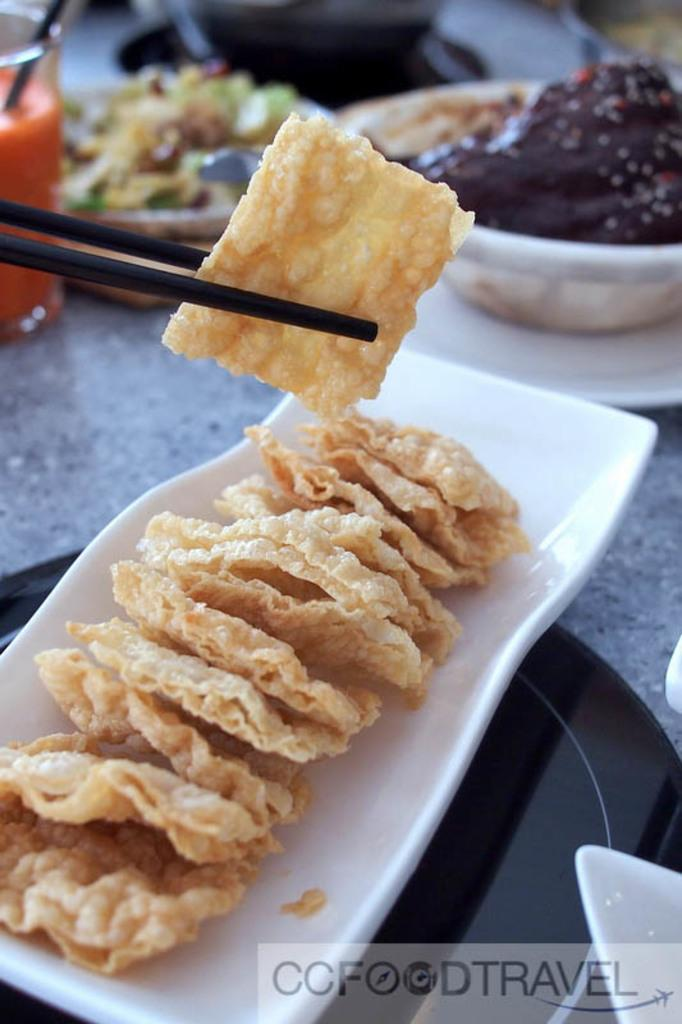What type of container is visible in the image? There is a glass in the image. What other type of container can be seen in the image? There is a bowl in the image. Are there any flat surfaces for serving food in the image? Yes, there is a plate in the image. What utensil is present in the image? There are chopsticks in the image. What can be found inside the containers or on the plate? There are food items in the image. How is the bead connected to the cap in the image? There is no bead or cap present in the image. 